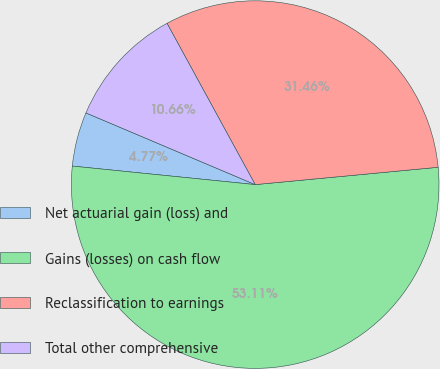Convert chart to OTSL. <chart><loc_0><loc_0><loc_500><loc_500><pie_chart><fcel>Net actuarial gain (loss) and<fcel>Gains (losses) on cash flow<fcel>Reclassification to earnings<fcel>Total other comprehensive<nl><fcel>4.77%<fcel>53.11%<fcel>31.46%<fcel>10.66%<nl></chart> 